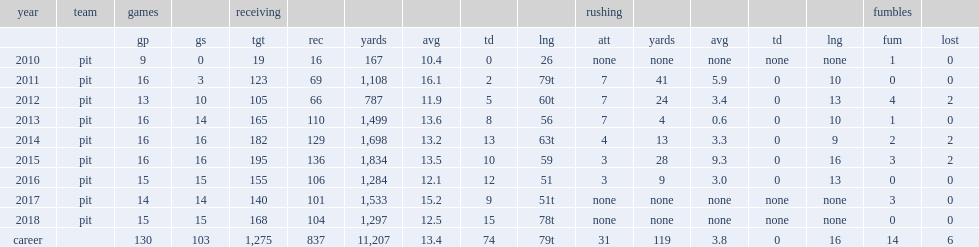How many receiving yards did brown get in 2018? 1297.0. 